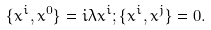<formula> <loc_0><loc_0><loc_500><loc_500>\{ x ^ { i } , x ^ { 0 } \} = i \lambda x ^ { i } ; \{ x ^ { i } , x ^ { j } \} = 0 .</formula> 